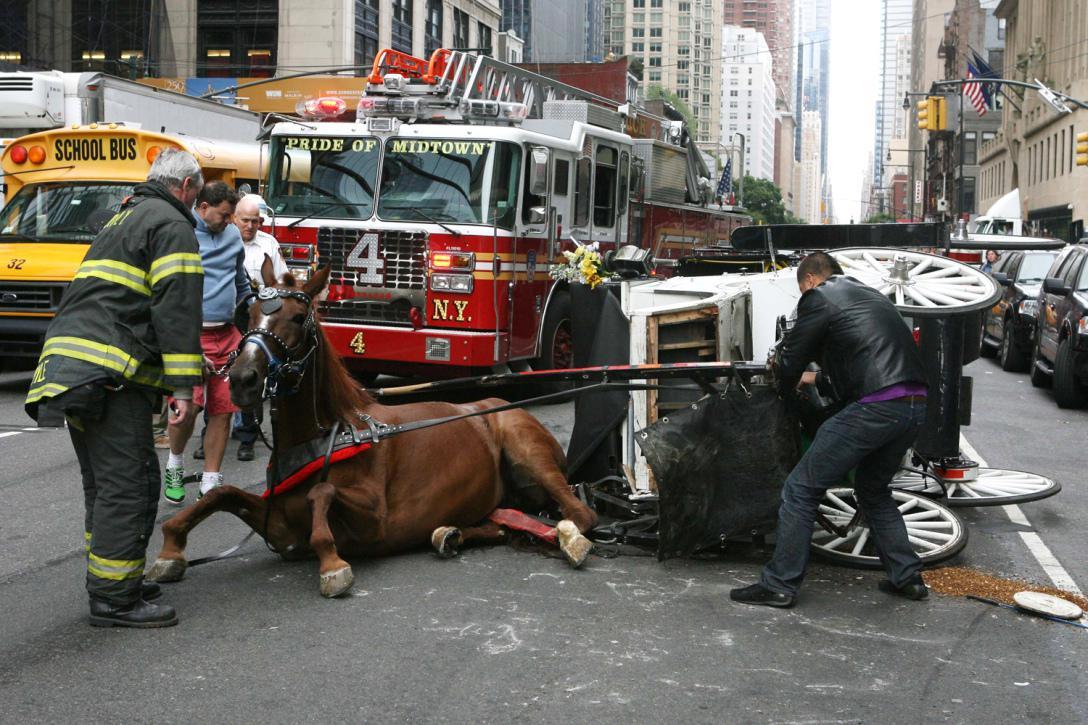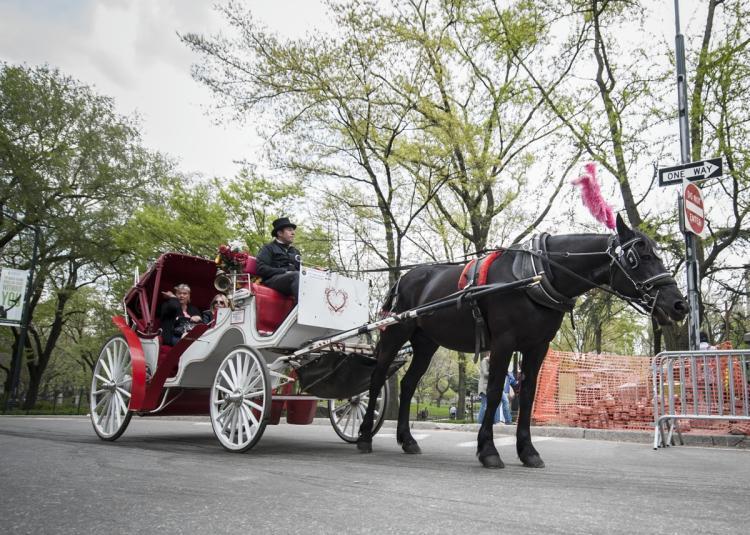The first image is the image on the left, the second image is the image on the right. For the images displayed, is the sentence "The white carriage is being pulled by a black horse." factually correct? Answer yes or no. Yes. 